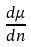Convert formula to latex. <formula><loc_0><loc_0><loc_500><loc_500>\frac { d \mu } { d n }</formula> 